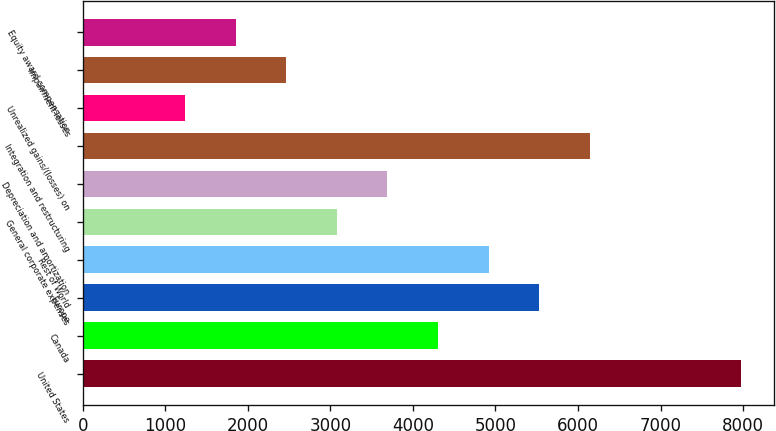<chart> <loc_0><loc_0><loc_500><loc_500><bar_chart><fcel>United States<fcel>Canada<fcel>Europe<fcel>Rest of World<fcel>General corporate expenses<fcel>Depreciation and amortization<fcel>Integration and restructuring<fcel>Unrealized gains/(losses) on<fcel>Impairment losses<fcel>Equity award compensation<nl><fcel>7980.1<fcel>4303.9<fcel>5529.3<fcel>4916.6<fcel>3078.5<fcel>3691.2<fcel>6142<fcel>1240.4<fcel>2465.8<fcel>1853.1<nl></chart> 